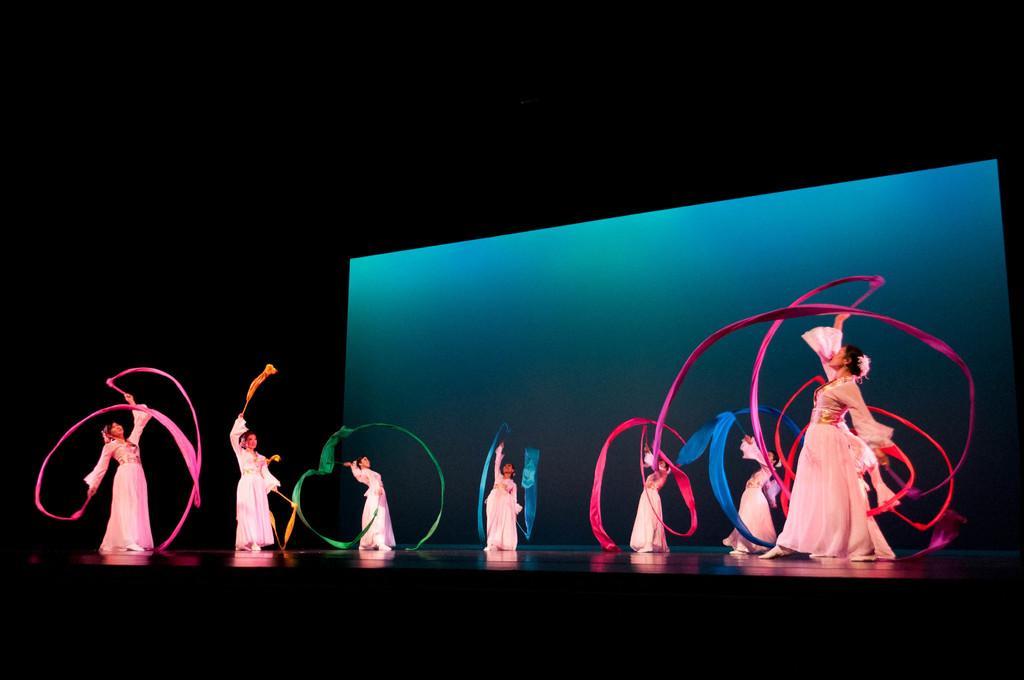Describe this image in one or two sentences. In this image we can see group of women performing on dais. In the background there is a screen. 